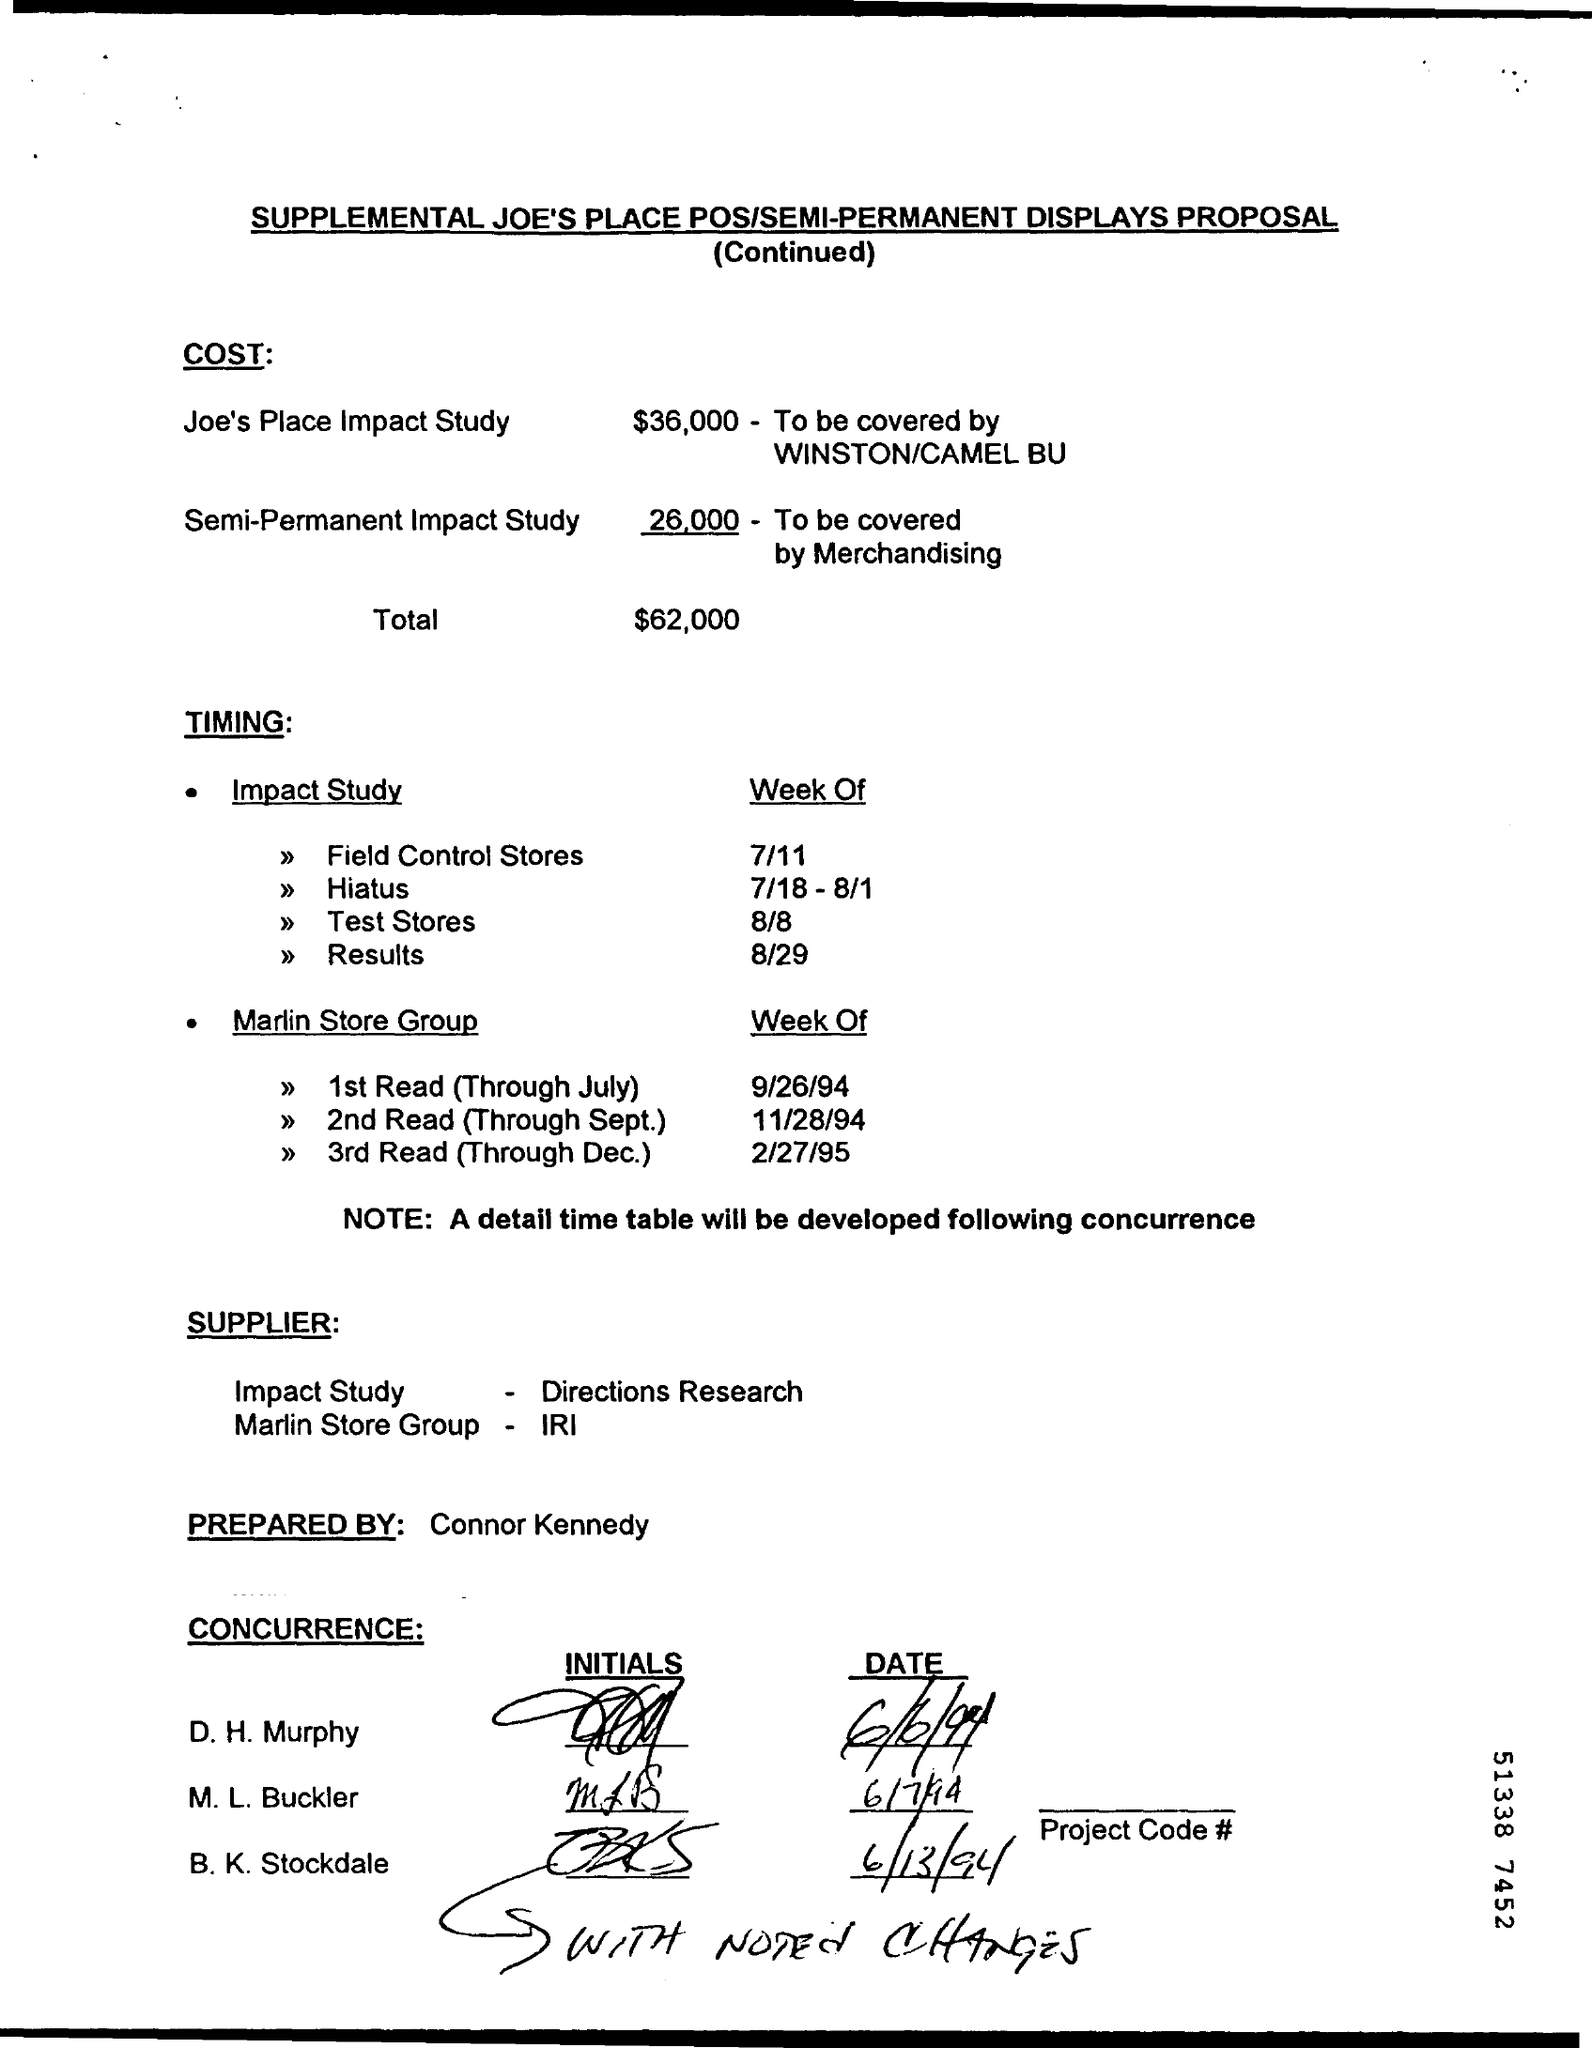What is the cost of Joe's Place Impact Study?
Give a very brief answer. 36,000. How will Semi-Permanent Impact study be covered?
Provide a short and direct response. By merchandising. Who has prepared the proposal?
Offer a terse response. Connor Kennedy. 